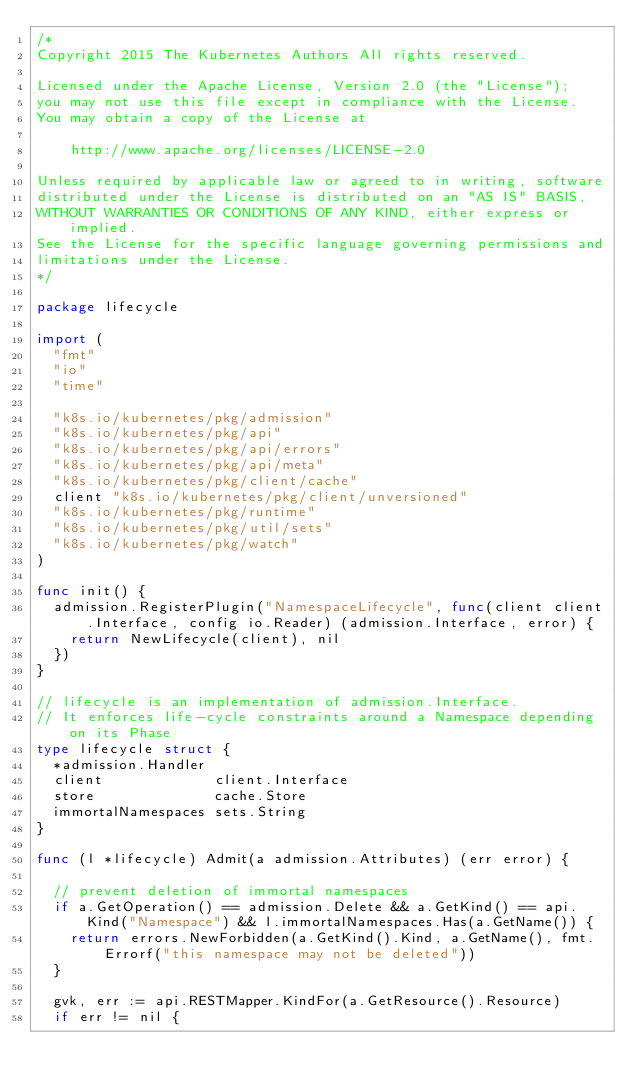Convert code to text. <code><loc_0><loc_0><loc_500><loc_500><_Go_>/*
Copyright 2015 The Kubernetes Authors All rights reserved.

Licensed under the Apache License, Version 2.0 (the "License");
you may not use this file except in compliance with the License.
You may obtain a copy of the License at

    http://www.apache.org/licenses/LICENSE-2.0

Unless required by applicable law or agreed to in writing, software
distributed under the License is distributed on an "AS IS" BASIS,
WITHOUT WARRANTIES OR CONDITIONS OF ANY KIND, either express or implied.
See the License for the specific language governing permissions and
limitations under the License.
*/

package lifecycle

import (
	"fmt"
	"io"
	"time"

	"k8s.io/kubernetes/pkg/admission"
	"k8s.io/kubernetes/pkg/api"
	"k8s.io/kubernetes/pkg/api/errors"
	"k8s.io/kubernetes/pkg/api/meta"
	"k8s.io/kubernetes/pkg/client/cache"
	client "k8s.io/kubernetes/pkg/client/unversioned"
	"k8s.io/kubernetes/pkg/runtime"
	"k8s.io/kubernetes/pkg/util/sets"
	"k8s.io/kubernetes/pkg/watch"
)

func init() {
	admission.RegisterPlugin("NamespaceLifecycle", func(client client.Interface, config io.Reader) (admission.Interface, error) {
		return NewLifecycle(client), nil
	})
}

// lifecycle is an implementation of admission.Interface.
// It enforces life-cycle constraints around a Namespace depending on its Phase
type lifecycle struct {
	*admission.Handler
	client             client.Interface
	store              cache.Store
	immortalNamespaces sets.String
}

func (l *lifecycle) Admit(a admission.Attributes) (err error) {

	// prevent deletion of immortal namespaces
	if a.GetOperation() == admission.Delete && a.GetKind() == api.Kind("Namespace") && l.immortalNamespaces.Has(a.GetName()) {
		return errors.NewForbidden(a.GetKind().Kind, a.GetName(), fmt.Errorf("this namespace may not be deleted"))
	}

	gvk, err := api.RESTMapper.KindFor(a.GetResource().Resource)
	if err != nil {</code> 